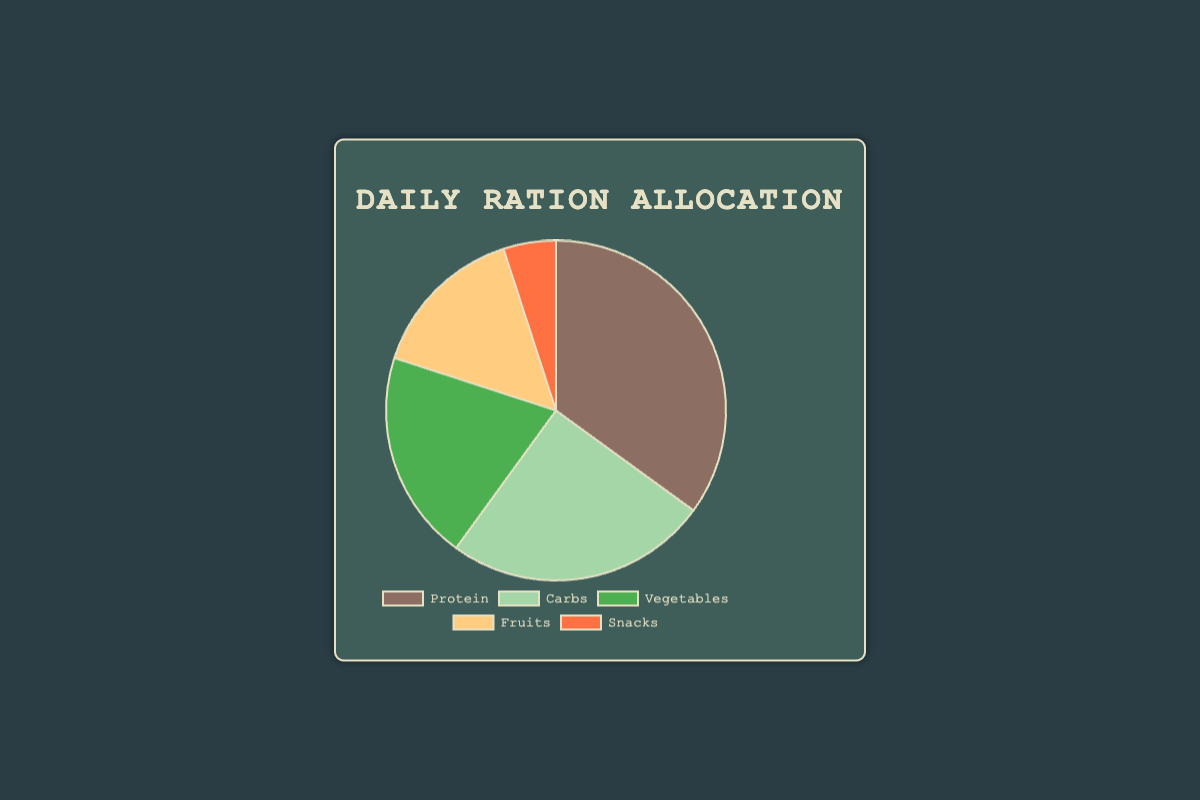Which category takes up the largest portion of the daily ration allocation? The pie chart shows that Protein has the largest portion with 35%.
Answer: Protein What is the difference in allocation percentage between Vegetables and Snacks? The pie chart shows Vegetables at 20% and Snacks at 5%. The difference is 20% - 5% = 15%.
Answer: 15% How many percentage points more are allocated to Carbs compared to Fruits? The allocation for Carbs is 25% and for Fruits is 15%. The difference is 25% - 15% = 10%.
Answer: 10% If you combine the allocations for Vegetables and Fruits, what is the total percentage? Vegetables are allocated 20% and Fruits are allocated 15%. Combined, the total is 20% + 15% = 35%.
Answer: 35% Which two categories together make up exactly half of the daily ration allocation? The chart shows that Protein is 35% and Carbs is 25%. Together they total 35% + 25% = 60%. Checking other combinations, Vegetables (20%) and Carbs (25%) add to 45%. Protein (35%) and Vegetables (20%) add to 55%. Vegetables (20%) and Fruits (15%) add to 35%. Vegetables (20%) and Snacks (5%) add to 25%. Fruits (15%) and Snacks (5%) add to 20%. The correct pairs are Protein (35%) and Vegetables (15%) which add to 50%.
Answer: Fruits and Vegetables Among Protein, Carbs, and Vegetables, which has the smallest allocation? The pie chart shows the allocations as Protein (35%), Carbs (25%), and Vegetables (20%). Vegetables have the smallest allocation among these three.
Answer: Vegetables By how many percentage points does the allocation for Protein exceed the total allocation for Fruits and Snacks combined? The chart shows Protein at 35%, Fruits at 15%, and Snacks at 5%. Combining Fruits and Snacks gives 15% + 5% = 20%. The difference is 35% - 20% = 15%.
Answer: 15% What's the average allocation percentage for Fruits, Vegetables, and Snacks? The percentages are Fruits (15%), Vegetables (20%), and Snacks (5%). Sum them up: 15 + 20 + 5 = 40. Then divide by 3 for the average: 40 / 3 ≈ 13.33.
Answer: 13.33% Which category is represented by the green section of the pie chart? By matching the color green in the chart legend, Vegetables are represented by green in the pie chart.
Answer: Vegetables 